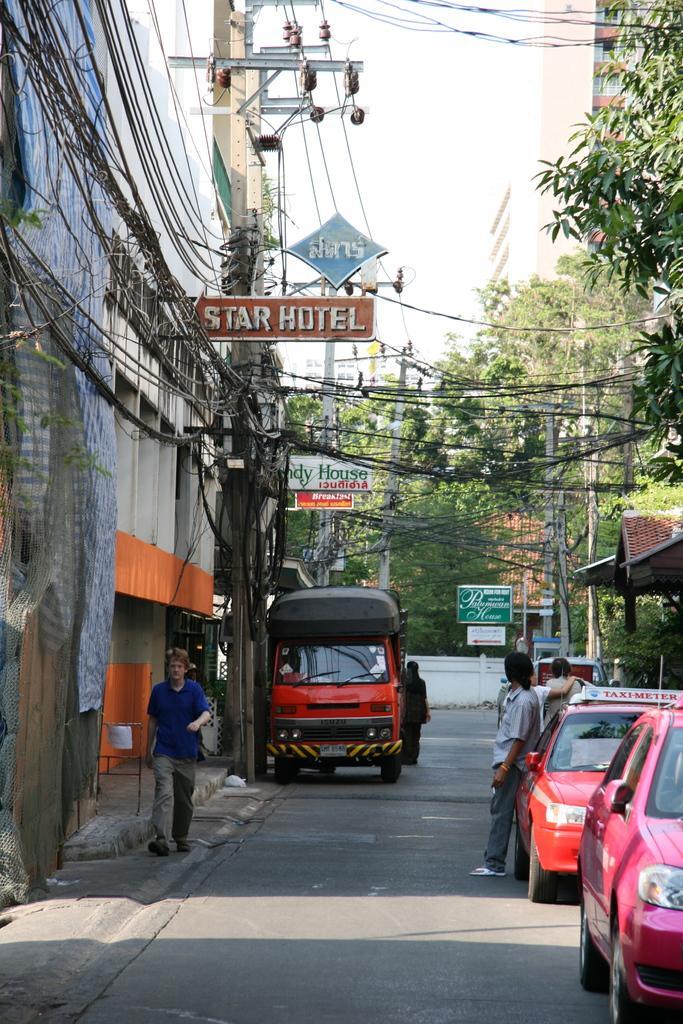Can you describe this image briefly? In this picture we can see a man in the blue t shirt is walking on the path and some people are standing. Behind the people there are some vehicles on the path, electric poles with cables and boards. Behind the poles there are trees, buildings and a sky. 